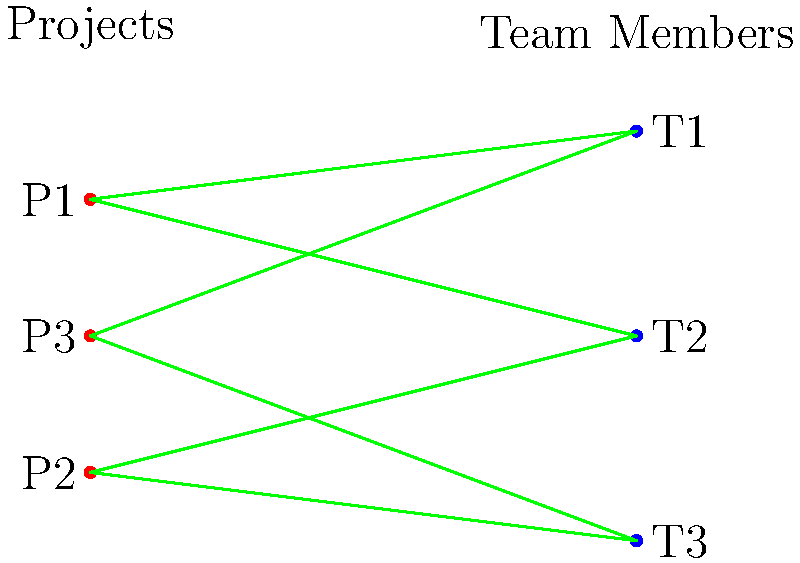Given the bipartite graph representing projects (P1, P2, P3) and team members (T1, T2, T3), what is the maximum number of projects that can be assigned to team members, ensuring each project is assigned to exactly one team member and each team member works on at most one project? Explain your reasoning using the concept of maximum matching in bipartite graphs. To solve this problem, we need to find the maximum matching in the given bipartite graph. Here's a step-by-step approach:

1. Identify the bipartite sets:
   Set A: Projects (P1, P2, P3)
   Set B: Team members (T1, T2, T3)

2. Observe the edges (possible assignments):
   P1 - T1, P1 - T2
   P2 - T2, P2 - T3
   P3 - T1, P3 - T3

3. Apply the concept of maximum matching:
   - Start with P1: Assign P1 to T1
   - Move to P2: Assign P2 to T2
   - For P3: T1 and T3 are available. Choose T3

4. Verify the matching:
   - P1 - T1
   - P2 - T2
   - P3 - T3

5. Check if this is a maximum matching:
   - All projects are assigned
   - All team members are utilized
   - No alternative matching can assign more projects

6. Conclusion:
   The maximum number of projects that can be assigned is 3, which is equal to the number of projects and team members.

This solution demonstrates an optimal resource allocation, maximizing the number of projects that can be simultaneously worked on while respecting the constraints of one project per team member and one team member per project.
Answer: 3 projects 